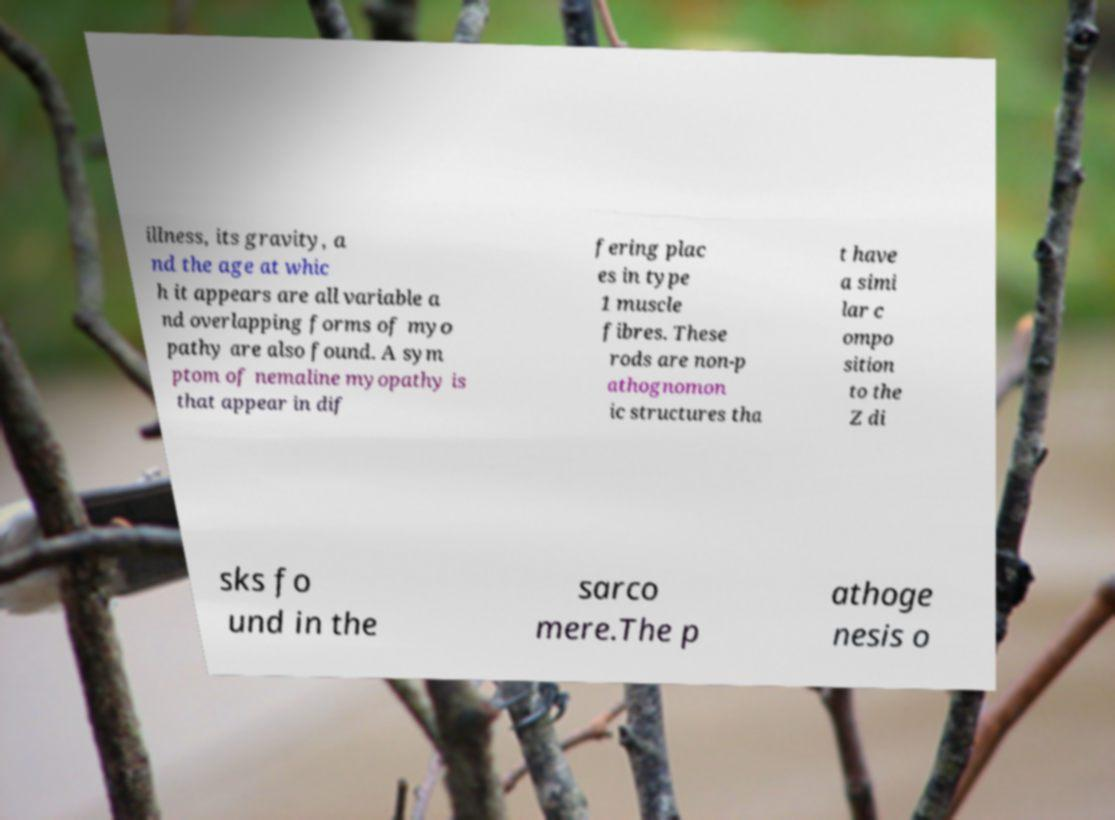Please read and relay the text visible in this image. What does it say? illness, its gravity, a nd the age at whic h it appears are all variable a nd overlapping forms of myo pathy are also found. A sym ptom of nemaline myopathy is that appear in dif fering plac es in type 1 muscle fibres. These rods are non-p athognomon ic structures tha t have a simi lar c ompo sition to the Z di sks fo und in the sarco mere.The p athoge nesis o 